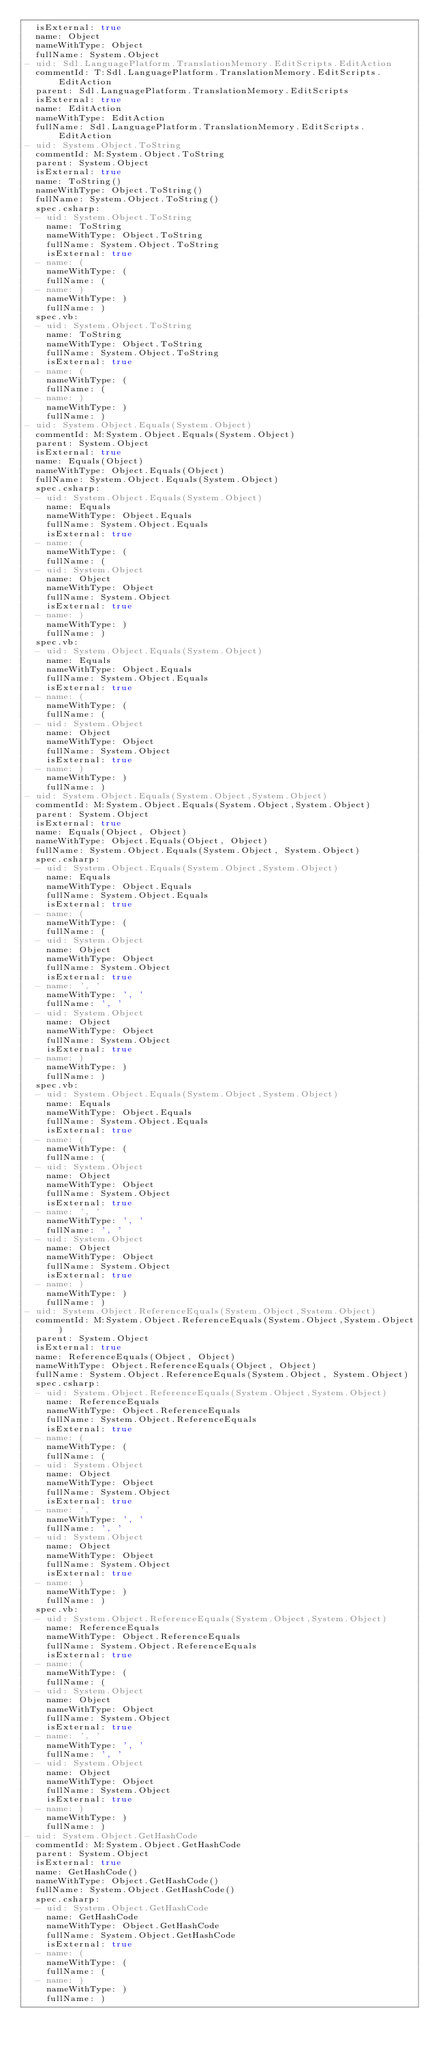Convert code to text. <code><loc_0><loc_0><loc_500><loc_500><_YAML_>  isExternal: true
  name: Object
  nameWithType: Object
  fullName: System.Object
- uid: Sdl.LanguagePlatform.TranslationMemory.EditScripts.EditAction
  commentId: T:Sdl.LanguagePlatform.TranslationMemory.EditScripts.EditAction
  parent: Sdl.LanguagePlatform.TranslationMemory.EditScripts
  isExternal: true
  name: EditAction
  nameWithType: EditAction
  fullName: Sdl.LanguagePlatform.TranslationMemory.EditScripts.EditAction
- uid: System.Object.ToString
  commentId: M:System.Object.ToString
  parent: System.Object
  isExternal: true
  name: ToString()
  nameWithType: Object.ToString()
  fullName: System.Object.ToString()
  spec.csharp:
  - uid: System.Object.ToString
    name: ToString
    nameWithType: Object.ToString
    fullName: System.Object.ToString
    isExternal: true
  - name: (
    nameWithType: (
    fullName: (
  - name: )
    nameWithType: )
    fullName: )
  spec.vb:
  - uid: System.Object.ToString
    name: ToString
    nameWithType: Object.ToString
    fullName: System.Object.ToString
    isExternal: true
  - name: (
    nameWithType: (
    fullName: (
  - name: )
    nameWithType: )
    fullName: )
- uid: System.Object.Equals(System.Object)
  commentId: M:System.Object.Equals(System.Object)
  parent: System.Object
  isExternal: true
  name: Equals(Object)
  nameWithType: Object.Equals(Object)
  fullName: System.Object.Equals(System.Object)
  spec.csharp:
  - uid: System.Object.Equals(System.Object)
    name: Equals
    nameWithType: Object.Equals
    fullName: System.Object.Equals
    isExternal: true
  - name: (
    nameWithType: (
    fullName: (
  - uid: System.Object
    name: Object
    nameWithType: Object
    fullName: System.Object
    isExternal: true
  - name: )
    nameWithType: )
    fullName: )
  spec.vb:
  - uid: System.Object.Equals(System.Object)
    name: Equals
    nameWithType: Object.Equals
    fullName: System.Object.Equals
    isExternal: true
  - name: (
    nameWithType: (
    fullName: (
  - uid: System.Object
    name: Object
    nameWithType: Object
    fullName: System.Object
    isExternal: true
  - name: )
    nameWithType: )
    fullName: )
- uid: System.Object.Equals(System.Object,System.Object)
  commentId: M:System.Object.Equals(System.Object,System.Object)
  parent: System.Object
  isExternal: true
  name: Equals(Object, Object)
  nameWithType: Object.Equals(Object, Object)
  fullName: System.Object.Equals(System.Object, System.Object)
  spec.csharp:
  - uid: System.Object.Equals(System.Object,System.Object)
    name: Equals
    nameWithType: Object.Equals
    fullName: System.Object.Equals
    isExternal: true
  - name: (
    nameWithType: (
    fullName: (
  - uid: System.Object
    name: Object
    nameWithType: Object
    fullName: System.Object
    isExternal: true
  - name: ', '
    nameWithType: ', '
    fullName: ', '
  - uid: System.Object
    name: Object
    nameWithType: Object
    fullName: System.Object
    isExternal: true
  - name: )
    nameWithType: )
    fullName: )
  spec.vb:
  - uid: System.Object.Equals(System.Object,System.Object)
    name: Equals
    nameWithType: Object.Equals
    fullName: System.Object.Equals
    isExternal: true
  - name: (
    nameWithType: (
    fullName: (
  - uid: System.Object
    name: Object
    nameWithType: Object
    fullName: System.Object
    isExternal: true
  - name: ', '
    nameWithType: ', '
    fullName: ', '
  - uid: System.Object
    name: Object
    nameWithType: Object
    fullName: System.Object
    isExternal: true
  - name: )
    nameWithType: )
    fullName: )
- uid: System.Object.ReferenceEquals(System.Object,System.Object)
  commentId: M:System.Object.ReferenceEquals(System.Object,System.Object)
  parent: System.Object
  isExternal: true
  name: ReferenceEquals(Object, Object)
  nameWithType: Object.ReferenceEquals(Object, Object)
  fullName: System.Object.ReferenceEquals(System.Object, System.Object)
  spec.csharp:
  - uid: System.Object.ReferenceEquals(System.Object,System.Object)
    name: ReferenceEquals
    nameWithType: Object.ReferenceEquals
    fullName: System.Object.ReferenceEquals
    isExternal: true
  - name: (
    nameWithType: (
    fullName: (
  - uid: System.Object
    name: Object
    nameWithType: Object
    fullName: System.Object
    isExternal: true
  - name: ', '
    nameWithType: ', '
    fullName: ', '
  - uid: System.Object
    name: Object
    nameWithType: Object
    fullName: System.Object
    isExternal: true
  - name: )
    nameWithType: )
    fullName: )
  spec.vb:
  - uid: System.Object.ReferenceEquals(System.Object,System.Object)
    name: ReferenceEquals
    nameWithType: Object.ReferenceEquals
    fullName: System.Object.ReferenceEquals
    isExternal: true
  - name: (
    nameWithType: (
    fullName: (
  - uid: System.Object
    name: Object
    nameWithType: Object
    fullName: System.Object
    isExternal: true
  - name: ', '
    nameWithType: ', '
    fullName: ', '
  - uid: System.Object
    name: Object
    nameWithType: Object
    fullName: System.Object
    isExternal: true
  - name: )
    nameWithType: )
    fullName: )
- uid: System.Object.GetHashCode
  commentId: M:System.Object.GetHashCode
  parent: System.Object
  isExternal: true
  name: GetHashCode()
  nameWithType: Object.GetHashCode()
  fullName: System.Object.GetHashCode()
  spec.csharp:
  - uid: System.Object.GetHashCode
    name: GetHashCode
    nameWithType: Object.GetHashCode
    fullName: System.Object.GetHashCode
    isExternal: true
  - name: (
    nameWithType: (
    fullName: (
  - name: )
    nameWithType: )
    fullName: )</code> 